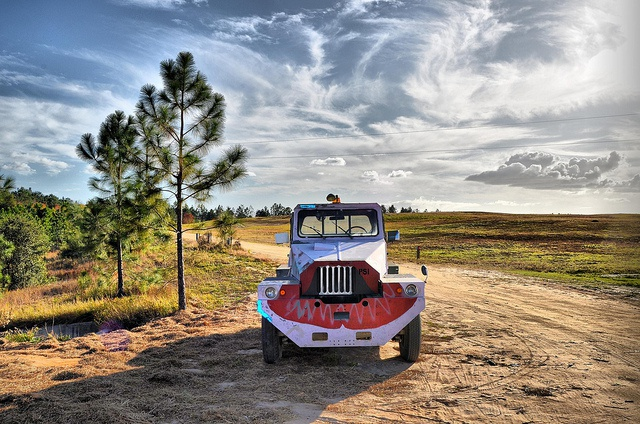Describe the objects in this image and their specific colors. I can see a truck in blue, black, darkgray, maroon, and brown tones in this image. 